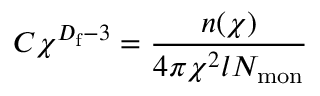Convert formula to latex. <formula><loc_0><loc_0><loc_500><loc_500>C \chi ^ { D _ { f } - 3 } = \frac { n ( \chi ) } { 4 \pi \chi ^ { 2 } l N _ { m o n } }</formula> 